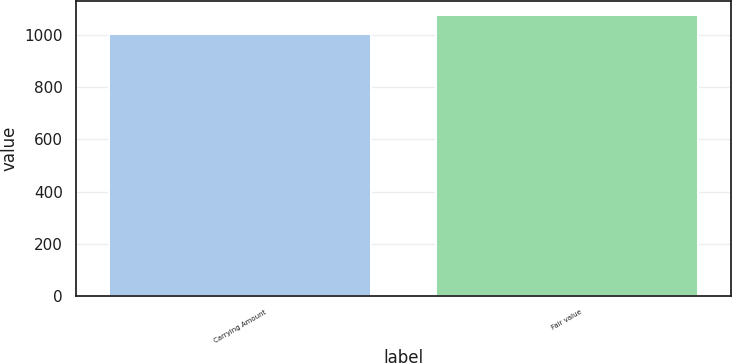Convert chart. <chart><loc_0><loc_0><loc_500><loc_500><bar_chart><fcel>Carrying Amount<fcel>Fair value<nl><fcel>1003<fcel>1076<nl></chart> 